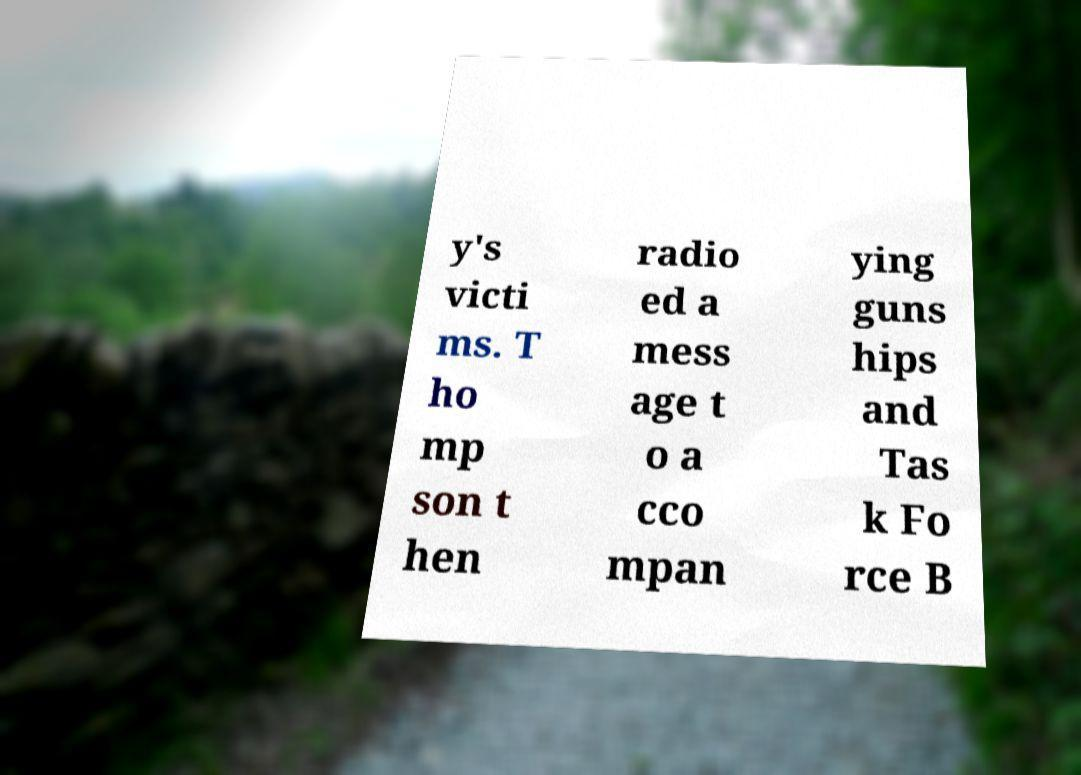Please read and relay the text visible in this image. What does it say? y's victi ms. T ho mp son t hen radio ed a mess age t o a cco mpan ying guns hips and Tas k Fo rce B 